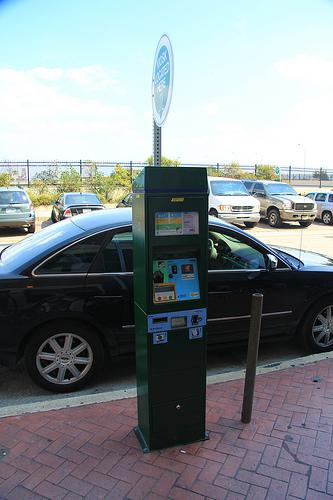Question: who captured this photo?
Choices:
A. An artist.
B. A photographer.
C. A reporter.
D. A blogger.
Answer with the letter. Answer: B Question: where was this photo taken?
Choices:
A. On a safari.
B. On a mountain top.
C. On a street.
D. On the beach.
Answer with the letter. Answer: C Question: what is the sidewalk made of?
Choices:
A. Cement.
B. Stones.
C. Wood.
D. Bricks.
Answer with the letter. Answer: D Question: how many cars are in the photo?
Choices:
A. One.
B. Seven.
C. Two.
D. Three.
Answer with the letter. Answer: B Question: what color is the sky?
Choices:
A. Grey.
B. Blue.
C. Black.
D. White.
Answer with the letter. Answer: B 